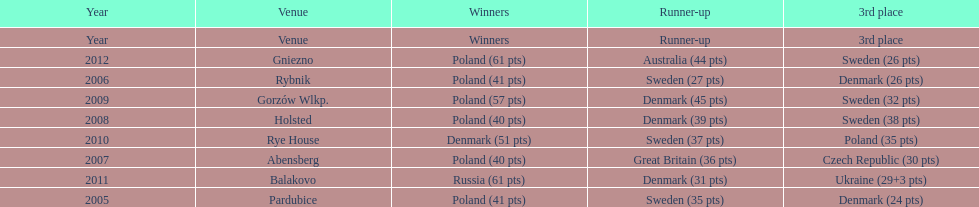What is the total number of points earned in the years 2009? 134. 